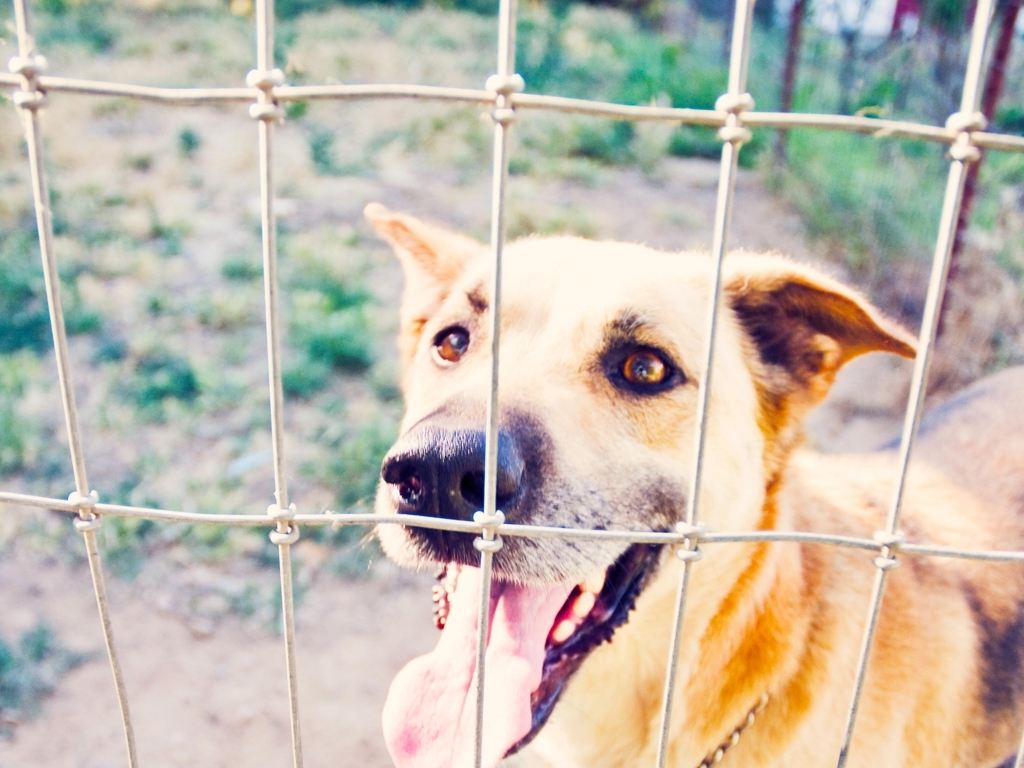How does the lighting affect the mood of the photo? The lighting in this image is soft and diffused, creating a gentle and serene atmosphere. It looks like it could be early morning or late afternoon, which adds a sense of tranquility. The warm tones suggest a friendly and inviting mood, despite the dog's confinement behind the fence. 